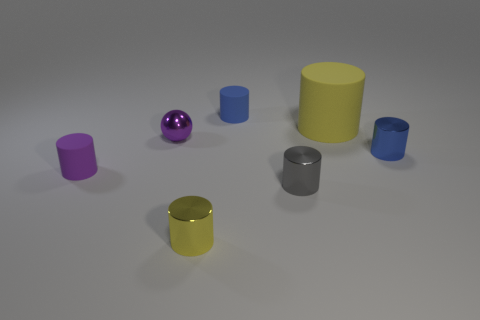Are there an equal number of small shiny cylinders to the left of the tiny yellow cylinder and spheres in front of the purple shiny sphere?
Your answer should be very brief. Yes. Are the cylinder behind the big yellow rubber cylinder and the gray thing made of the same material?
Offer a very short reply. No. The cylinder that is right of the purple cylinder and left of the blue rubber thing is what color?
Provide a short and direct response. Yellow. How many shiny cylinders are on the left side of the small cylinder behind the tiny sphere?
Provide a succinct answer. 1. What is the material of the big yellow thing that is the same shape as the tiny gray metal object?
Your answer should be compact. Rubber. The big cylinder has what color?
Keep it short and to the point. Yellow. What number of objects are either tiny purple metallic spheres or yellow metallic cylinders?
Make the answer very short. 2. What shape is the yellow thing that is in front of the small rubber cylinder in front of the small purple ball?
Make the answer very short. Cylinder. How many other objects are there of the same material as the small purple cylinder?
Provide a succinct answer. 2. Does the big thing have the same material as the blue cylinder that is in front of the blue rubber thing?
Offer a terse response. No. 